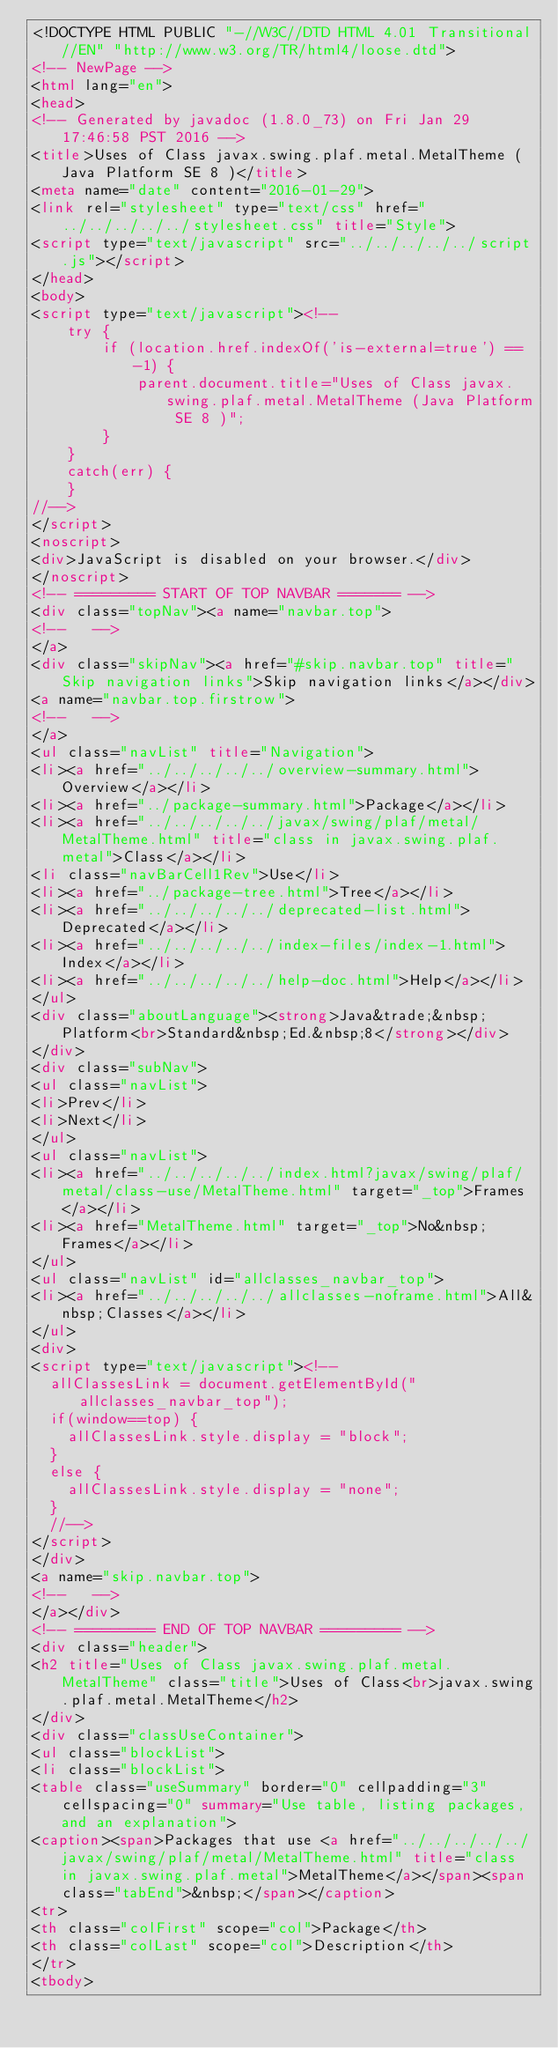<code> <loc_0><loc_0><loc_500><loc_500><_HTML_><!DOCTYPE HTML PUBLIC "-//W3C//DTD HTML 4.01 Transitional//EN" "http://www.w3.org/TR/html4/loose.dtd">
<!-- NewPage -->
<html lang="en">
<head>
<!-- Generated by javadoc (1.8.0_73) on Fri Jan 29 17:46:58 PST 2016 -->
<title>Uses of Class javax.swing.plaf.metal.MetalTheme (Java Platform SE 8 )</title>
<meta name="date" content="2016-01-29">
<link rel="stylesheet" type="text/css" href="../../../../../stylesheet.css" title="Style">
<script type="text/javascript" src="../../../../../script.js"></script>
</head>
<body>
<script type="text/javascript"><!--
    try {
        if (location.href.indexOf('is-external=true') == -1) {
            parent.document.title="Uses of Class javax.swing.plaf.metal.MetalTheme (Java Platform SE 8 )";
        }
    }
    catch(err) {
    }
//-->
</script>
<noscript>
<div>JavaScript is disabled on your browser.</div>
</noscript>
<!-- ========= START OF TOP NAVBAR ======= -->
<div class="topNav"><a name="navbar.top">
<!--   -->
</a>
<div class="skipNav"><a href="#skip.navbar.top" title="Skip navigation links">Skip navigation links</a></div>
<a name="navbar.top.firstrow">
<!--   -->
</a>
<ul class="navList" title="Navigation">
<li><a href="../../../../../overview-summary.html">Overview</a></li>
<li><a href="../package-summary.html">Package</a></li>
<li><a href="../../../../../javax/swing/plaf/metal/MetalTheme.html" title="class in javax.swing.plaf.metal">Class</a></li>
<li class="navBarCell1Rev">Use</li>
<li><a href="../package-tree.html">Tree</a></li>
<li><a href="../../../../../deprecated-list.html">Deprecated</a></li>
<li><a href="../../../../../index-files/index-1.html">Index</a></li>
<li><a href="../../../../../help-doc.html">Help</a></li>
</ul>
<div class="aboutLanguage"><strong>Java&trade;&nbsp;Platform<br>Standard&nbsp;Ed.&nbsp;8</strong></div>
</div>
<div class="subNav">
<ul class="navList">
<li>Prev</li>
<li>Next</li>
</ul>
<ul class="navList">
<li><a href="../../../../../index.html?javax/swing/plaf/metal/class-use/MetalTheme.html" target="_top">Frames</a></li>
<li><a href="MetalTheme.html" target="_top">No&nbsp;Frames</a></li>
</ul>
<ul class="navList" id="allclasses_navbar_top">
<li><a href="../../../../../allclasses-noframe.html">All&nbsp;Classes</a></li>
</ul>
<div>
<script type="text/javascript"><!--
  allClassesLink = document.getElementById("allclasses_navbar_top");
  if(window==top) {
    allClassesLink.style.display = "block";
  }
  else {
    allClassesLink.style.display = "none";
  }
  //-->
</script>
</div>
<a name="skip.navbar.top">
<!--   -->
</a></div>
<!-- ========= END OF TOP NAVBAR ========= -->
<div class="header">
<h2 title="Uses of Class javax.swing.plaf.metal.MetalTheme" class="title">Uses of Class<br>javax.swing.plaf.metal.MetalTheme</h2>
</div>
<div class="classUseContainer">
<ul class="blockList">
<li class="blockList">
<table class="useSummary" border="0" cellpadding="3" cellspacing="0" summary="Use table, listing packages, and an explanation">
<caption><span>Packages that use <a href="../../../../../javax/swing/plaf/metal/MetalTheme.html" title="class in javax.swing.plaf.metal">MetalTheme</a></span><span class="tabEnd">&nbsp;</span></caption>
<tr>
<th class="colFirst" scope="col">Package</th>
<th class="colLast" scope="col">Description</th>
</tr>
<tbody></code> 